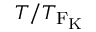<formula> <loc_0><loc_0><loc_500><loc_500>T / T _ { F _ { \mathrm { K } } }</formula> 